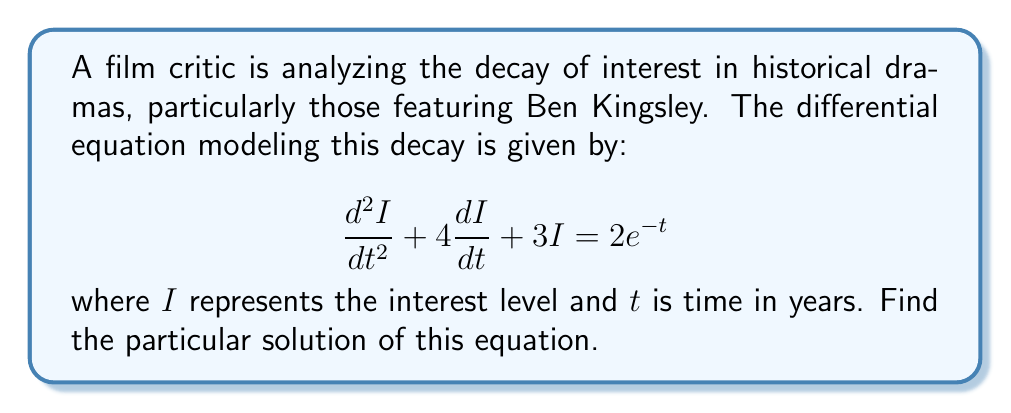Provide a solution to this math problem. To find the particular solution, we'll use the method of undetermined coefficients:

1) The right-hand side of the equation is $2e^{-t}$, so we assume a particular solution of the form:

   $I_p = Ae^{-t}$

2) We need to find $\frac{dI_p}{dt}$ and $\frac{d^2I_p}{dt^2}$:

   $\frac{dI_p}{dt} = -Ae^{-t}$
   $\frac{d^2I_p}{dt^2} = Ae^{-t}$

3) Substitute these into the original equation:

   $Ae^{-t} + 4(-Ae^{-t}) + 3Ae^{-t} = 2e^{-t}$

4) Simplify:

   $(A - 4A + 3A)e^{-t} = 2e^{-t}$
   $0A = 2$

5) Solve for A:

   $A = 2$

6) Therefore, the particular solution is:

   $I_p = 2e^{-t}$

This solution represents the specific response of the system to the forcing function $2e^{-t}$, which models the external factors affecting the interest in historical dramas featuring Ben Kingsley.
Answer: $I_p = 2e^{-t}$ 